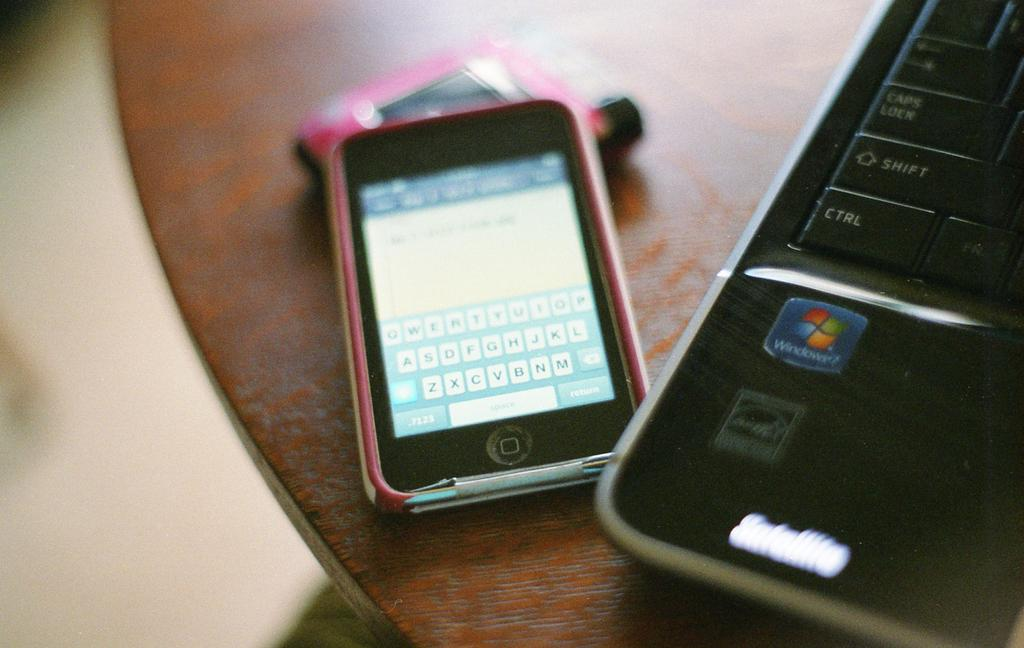<image>
Create a compact narrative representing the image presented. A phone next to a laptop that runs the Windows 7 operating system 